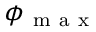Convert formula to latex. <formula><loc_0><loc_0><loc_500><loc_500>\phi _ { m a x }</formula> 